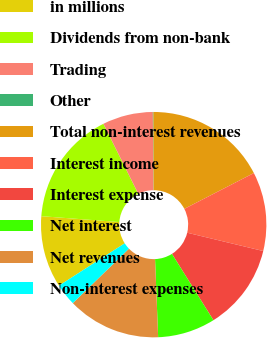<chart> <loc_0><loc_0><loc_500><loc_500><pie_chart><fcel>in millions<fcel>Dividends from non-bank<fcel>Trading<fcel>Other<fcel>Total non-interest revenues<fcel>Interest income<fcel>Interest expense<fcel>Net interest<fcel>Net revenues<fcel>Non-interest expenses<nl><fcel>10.31%<fcel>16.44%<fcel>7.24%<fcel>0.09%<fcel>17.46%<fcel>11.33%<fcel>12.35%<fcel>8.26%<fcel>13.37%<fcel>3.15%<nl></chart> 